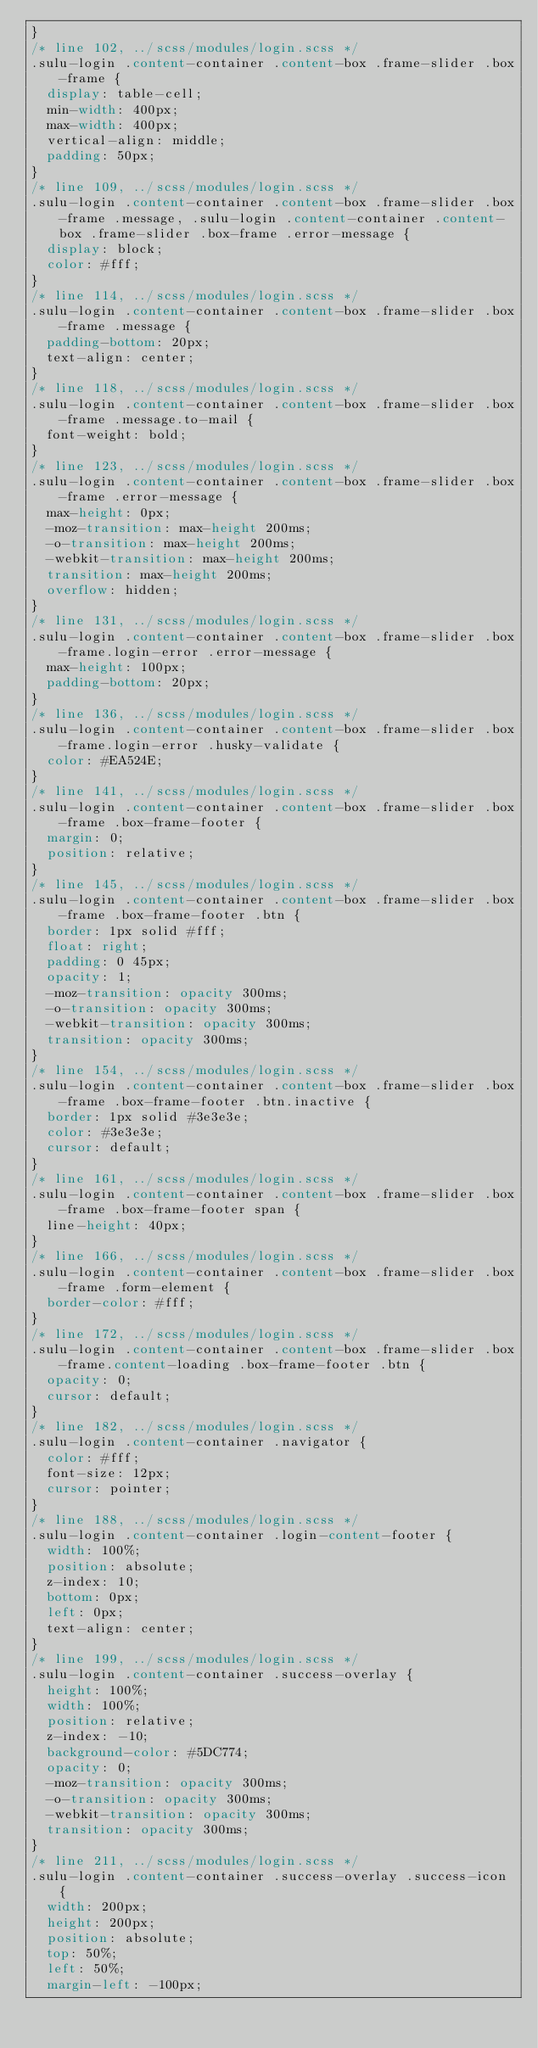<code> <loc_0><loc_0><loc_500><loc_500><_CSS_>}
/* line 102, ../scss/modules/login.scss */
.sulu-login .content-container .content-box .frame-slider .box-frame {
  display: table-cell;
  min-width: 400px;
  max-width: 400px;
  vertical-align: middle;
  padding: 50px;
}
/* line 109, ../scss/modules/login.scss */
.sulu-login .content-container .content-box .frame-slider .box-frame .message, .sulu-login .content-container .content-box .frame-slider .box-frame .error-message {
  display: block;
  color: #fff;
}
/* line 114, ../scss/modules/login.scss */
.sulu-login .content-container .content-box .frame-slider .box-frame .message {
  padding-bottom: 20px;
  text-align: center;
}
/* line 118, ../scss/modules/login.scss */
.sulu-login .content-container .content-box .frame-slider .box-frame .message.to-mail {
  font-weight: bold;
}
/* line 123, ../scss/modules/login.scss */
.sulu-login .content-container .content-box .frame-slider .box-frame .error-message {
  max-height: 0px;
  -moz-transition: max-height 200ms;
  -o-transition: max-height 200ms;
  -webkit-transition: max-height 200ms;
  transition: max-height 200ms;
  overflow: hidden;
}
/* line 131, ../scss/modules/login.scss */
.sulu-login .content-container .content-box .frame-slider .box-frame.login-error .error-message {
  max-height: 100px;
  padding-bottom: 20px;
}
/* line 136, ../scss/modules/login.scss */
.sulu-login .content-container .content-box .frame-slider .box-frame.login-error .husky-validate {
  color: #EA524E;
}
/* line 141, ../scss/modules/login.scss */
.sulu-login .content-container .content-box .frame-slider .box-frame .box-frame-footer {
  margin: 0;
  position: relative;
}
/* line 145, ../scss/modules/login.scss */
.sulu-login .content-container .content-box .frame-slider .box-frame .box-frame-footer .btn {
  border: 1px solid #fff;
  float: right;
  padding: 0 45px;
  opacity: 1;
  -moz-transition: opacity 300ms;
  -o-transition: opacity 300ms;
  -webkit-transition: opacity 300ms;
  transition: opacity 300ms;
}
/* line 154, ../scss/modules/login.scss */
.sulu-login .content-container .content-box .frame-slider .box-frame .box-frame-footer .btn.inactive {
  border: 1px solid #3e3e3e;
  color: #3e3e3e;
  cursor: default;
}
/* line 161, ../scss/modules/login.scss */
.sulu-login .content-container .content-box .frame-slider .box-frame .box-frame-footer span {
  line-height: 40px;
}
/* line 166, ../scss/modules/login.scss */
.sulu-login .content-container .content-box .frame-slider .box-frame .form-element {
  border-color: #fff;
}
/* line 172, ../scss/modules/login.scss */
.sulu-login .content-container .content-box .frame-slider .box-frame.content-loading .box-frame-footer .btn {
  opacity: 0;
  cursor: default;
}
/* line 182, ../scss/modules/login.scss */
.sulu-login .content-container .navigator {
  color: #fff;
  font-size: 12px;
  cursor: pointer;
}
/* line 188, ../scss/modules/login.scss */
.sulu-login .content-container .login-content-footer {
  width: 100%;
  position: absolute;
  z-index: 10;
  bottom: 0px;
  left: 0px;
  text-align: center;
}
/* line 199, ../scss/modules/login.scss */
.sulu-login .content-container .success-overlay {
  height: 100%;
  width: 100%;
  position: relative;
  z-index: -10;
  background-color: #5DC774;
  opacity: 0;
  -moz-transition: opacity 300ms;
  -o-transition: opacity 300ms;
  -webkit-transition: opacity 300ms;
  transition: opacity 300ms;
}
/* line 211, ../scss/modules/login.scss */
.sulu-login .content-container .success-overlay .success-icon {
  width: 200px;
  height: 200px;
  position: absolute;
  top: 50%;
  left: 50%;
  margin-left: -100px;</code> 